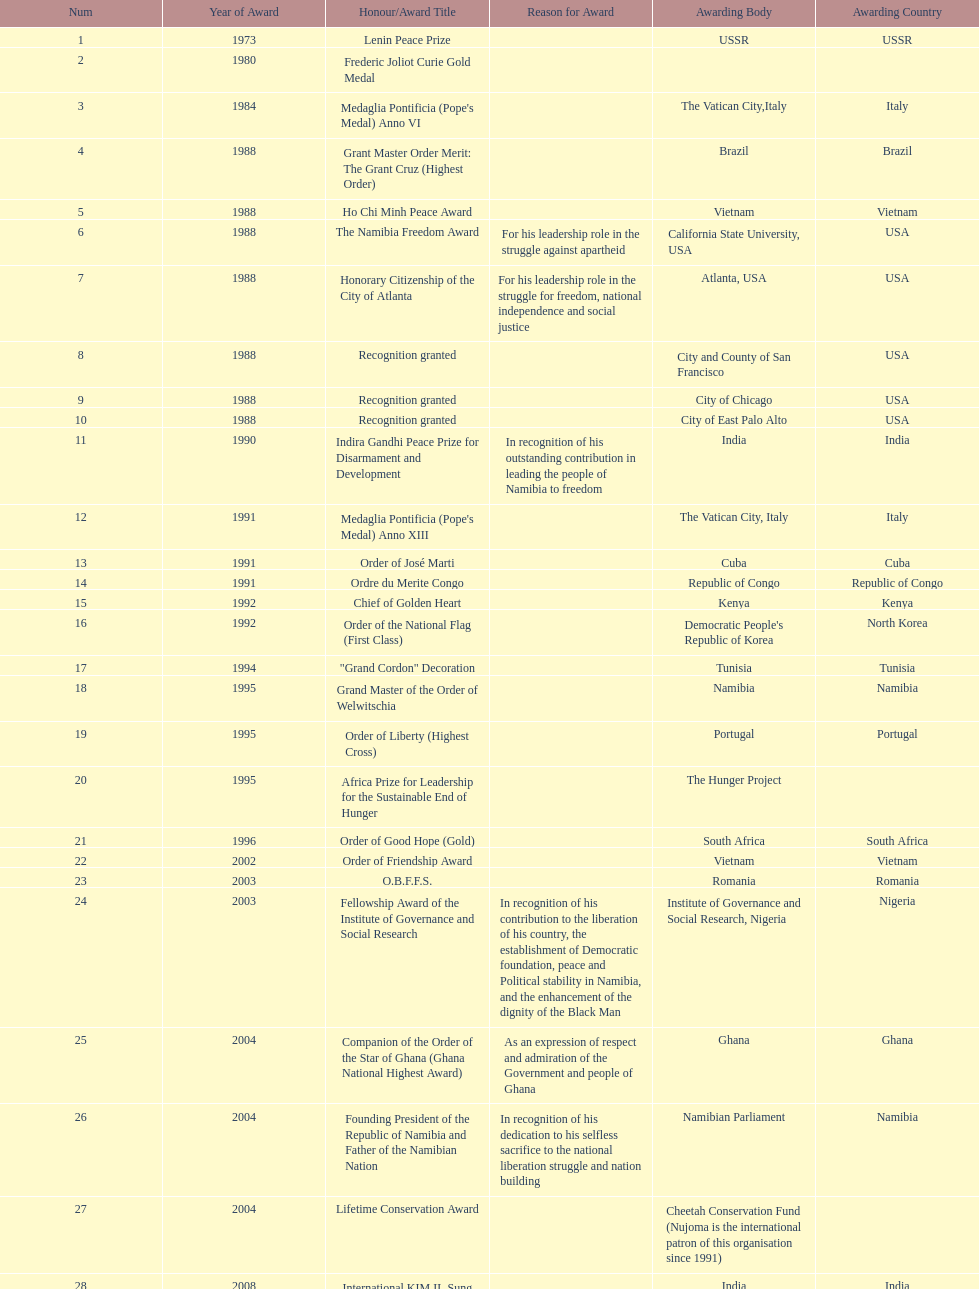Which year was the most honors/award titles given? 1988. 